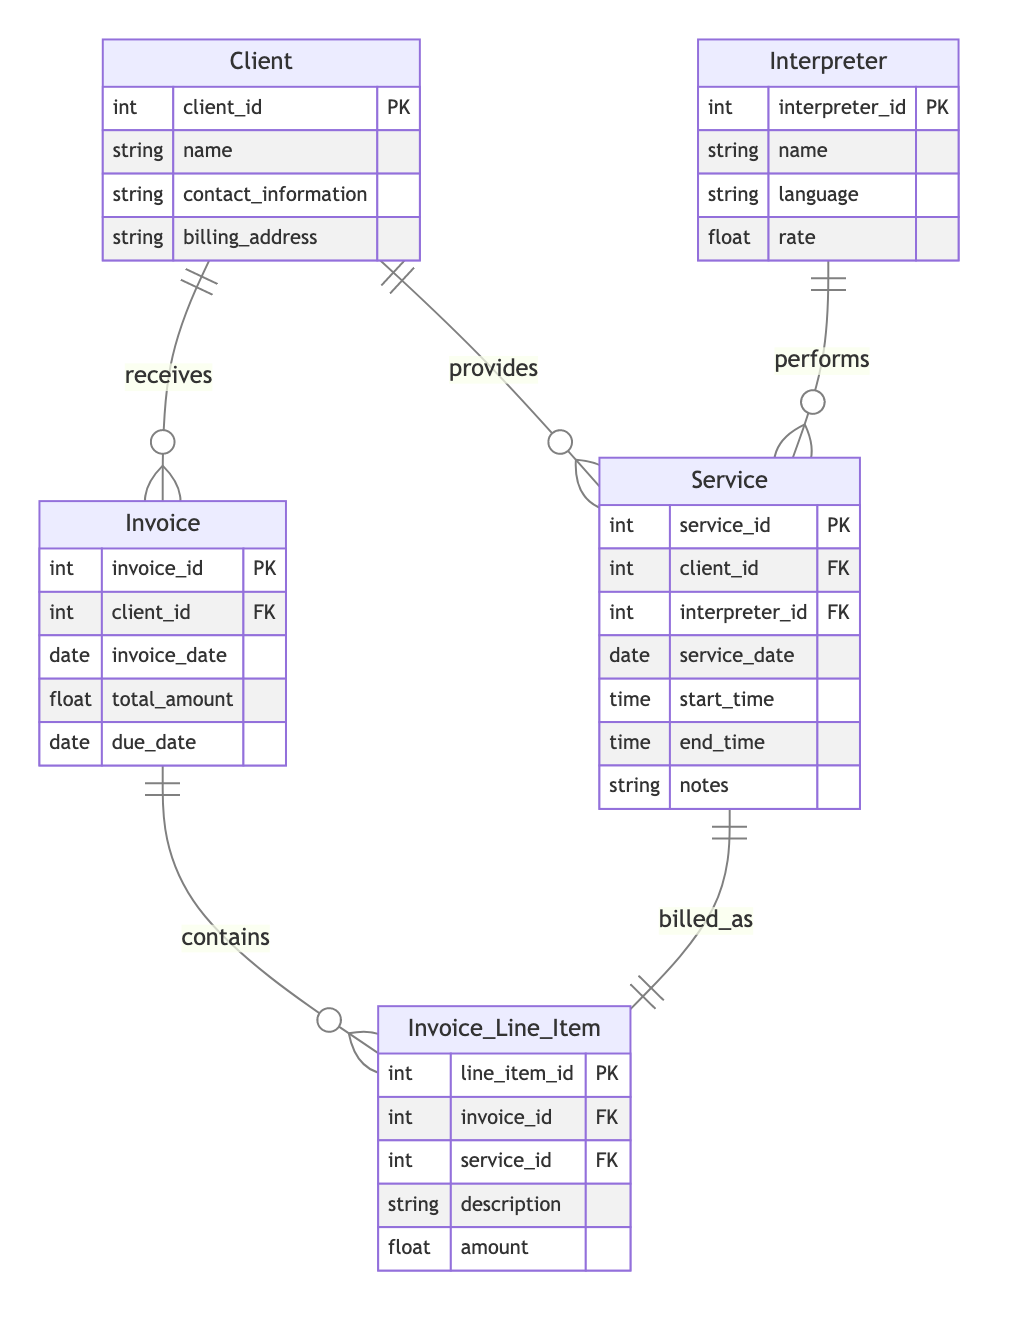What is the primary key of the Client entity? The primary key is the unique identifier for the Client entity, which is specified as "client_id" in the diagram.
Answer: client_id How many attributes does the Invoice entity have? By counting the listed attributes in the Invoice entity, we find there are five attributes: invoice_id, client_id, invoice_date, total_amount, and due_date.
Answer: five Which entities have a one-to-many relationship with the Service entity? The diagram shows that both the Client and the Interpreter entities have a one-to-many relationship with the Service entity, meaning one client can have multiple services, and one interpreter can perform multiple services.
Answer: Client, Interpreter What is the relationship type between Service and Invoice_Line_Item? The diagram indicates that there is a one-to-one relationship between Service and Invoice_Line_Item, meaning each service corresponds to exactly one invoice line item.
Answer: one-to-one How many foreign keys are present in the Invoice entity? The Invoice entity has one foreign key, which is "client_id" that references the Client entity, allowing it to link to a client.
Answer: one What is the purpose of the Invoice_Line_Item entity? The Invoice_Line_Item entity serves to detail the individual components included in an invoice, linking the service provided to an invoice and providing the amounts charged.
Answer: detail components How many total entities are represented in the diagram? Upon reviewing the diagram, we can count six entities: Client, Interpreter, Service, Invoice, Invoice_Line_Item, and there are no other entities represented.
Answer: six What does the term "FK" refer to in the diagram? In the context of the diagram, "FK" stands for Foreign Key, which is a field in one entity that links to the primary key of another entity, used to establish a relationship between the two.
Answer: Foreign Key Which entity receives invoices according to the diagram? The diagram shows that the Client entity is the one that receives invoices, as indicated by the relationship from the Client to the Invoice entity.
Answer: Client 